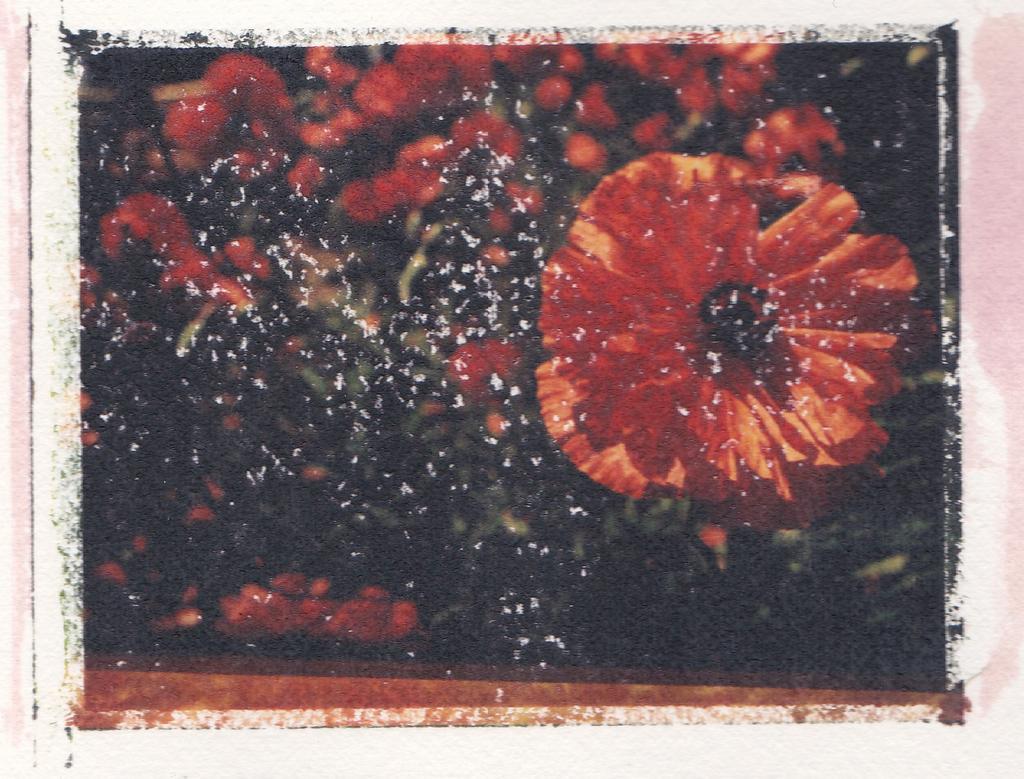Describe this image in one or two sentences. In this image I can see few red color flowers and black background. 